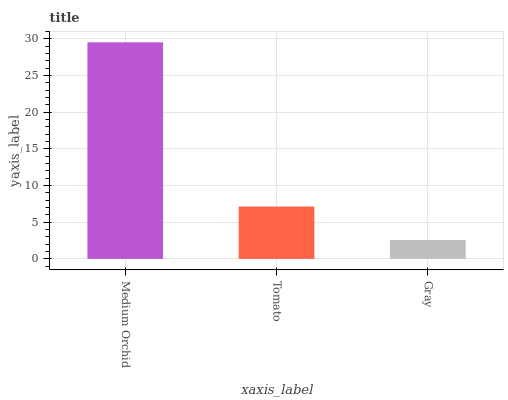Is Gray the minimum?
Answer yes or no. Yes. Is Medium Orchid the maximum?
Answer yes or no. Yes. Is Tomato the minimum?
Answer yes or no. No. Is Tomato the maximum?
Answer yes or no. No. Is Medium Orchid greater than Tomato?
Answer yes or no. Yes. Is Tomato less than Medium Orchid?
Answer yes or no. Yes. Is Tomato greater than Medium Orchid?
Answer yes or no. No. Is Medium Orchid less than Tomato?
Answer yes or no. No. Is Tomato the high median?
Answer yes or no. Yes. Is Tomato the low median?
Answer yes or no. Yes. Is Medium Orchid the high median?
Answer yes or no. No. Is Gray the low median?
Answer yes or no. No. 